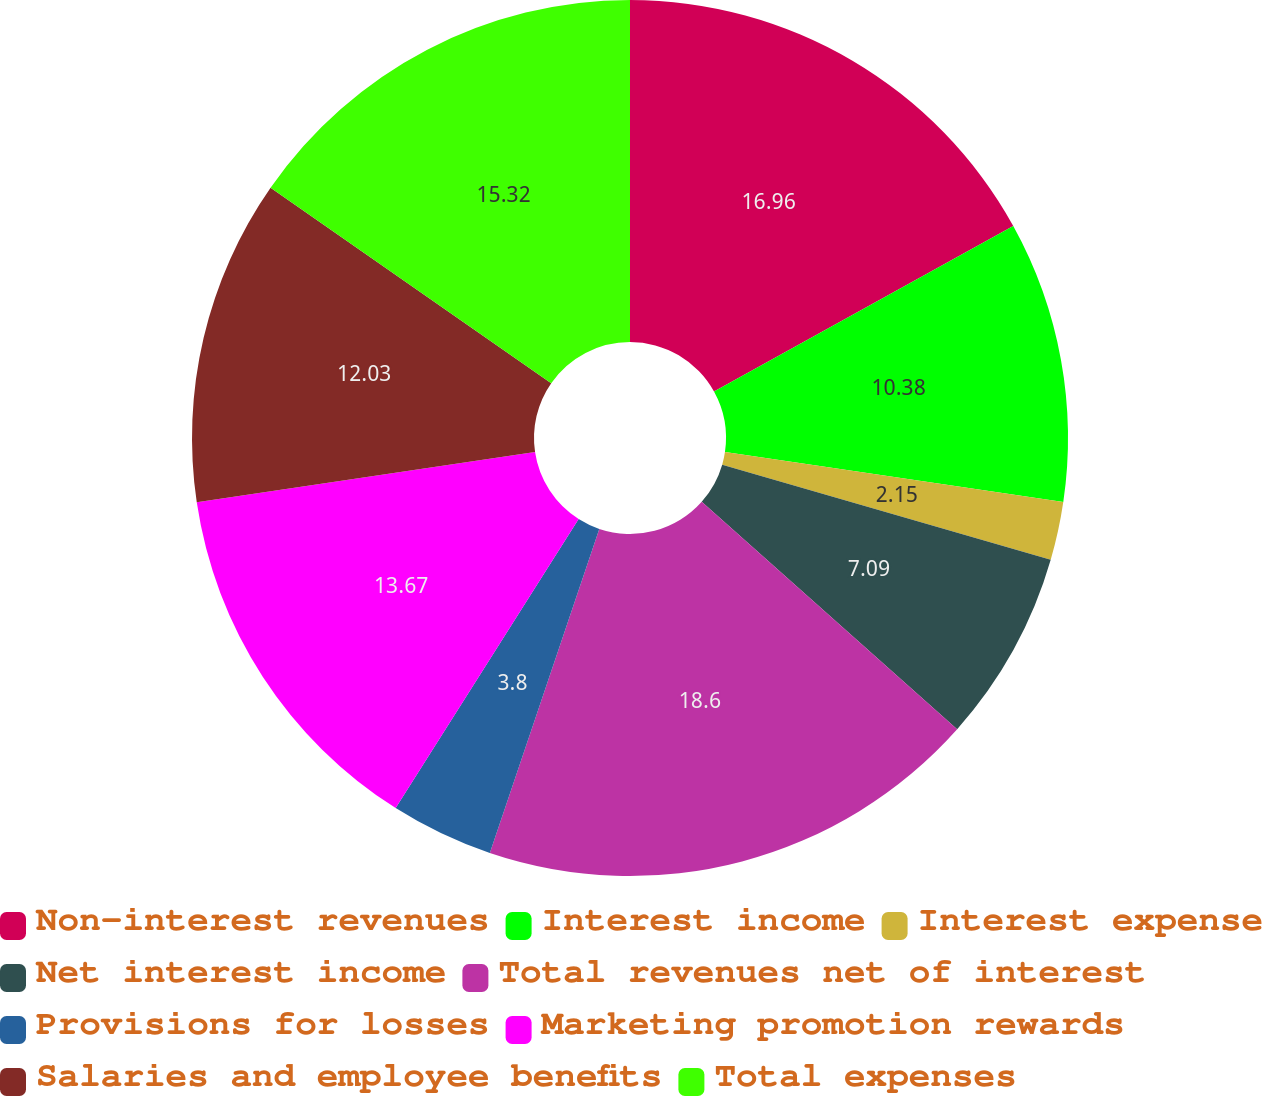Convert chart. <chart><loc_0><loc_0><loc_500><loc_500><pie_chart><fcel>Non-interest revenues<fcel>Interest income<fcel>Interest expense<fcel>Net interest income<fcel>Total revenues net of interest<fcel>Provisions for losses<fcel>Marketing promotion rewards<fcel>Salaries and employee benefits<fcel>Total expenses<nl><fcel>16.96%<fcel>10.38%<fcel>2.15%<fcel>7.09%<fcel>18.61%<fcel>3.8%<fcel>13.67%<fcel>12.03%<fcel>15.32%<nl></chart> 